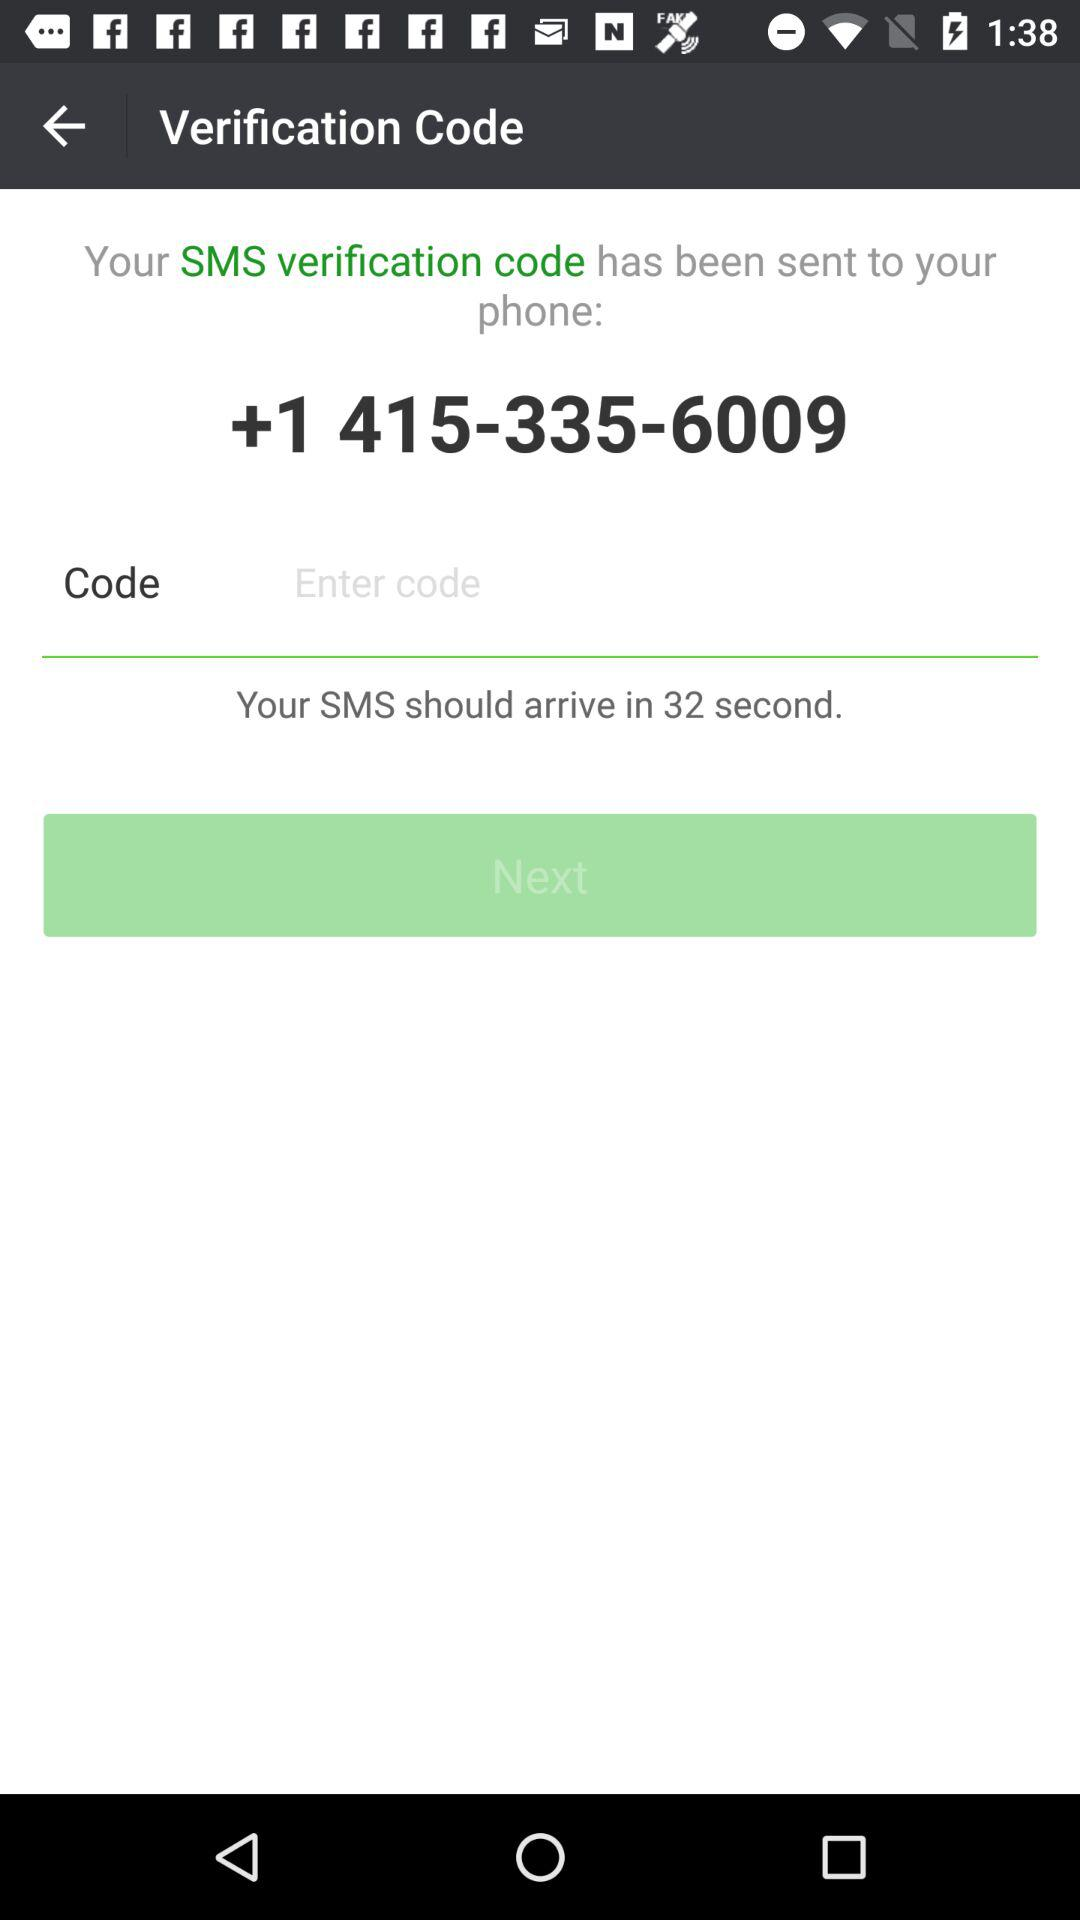What is the contact number? The contact number is +1 415-335-6009. 